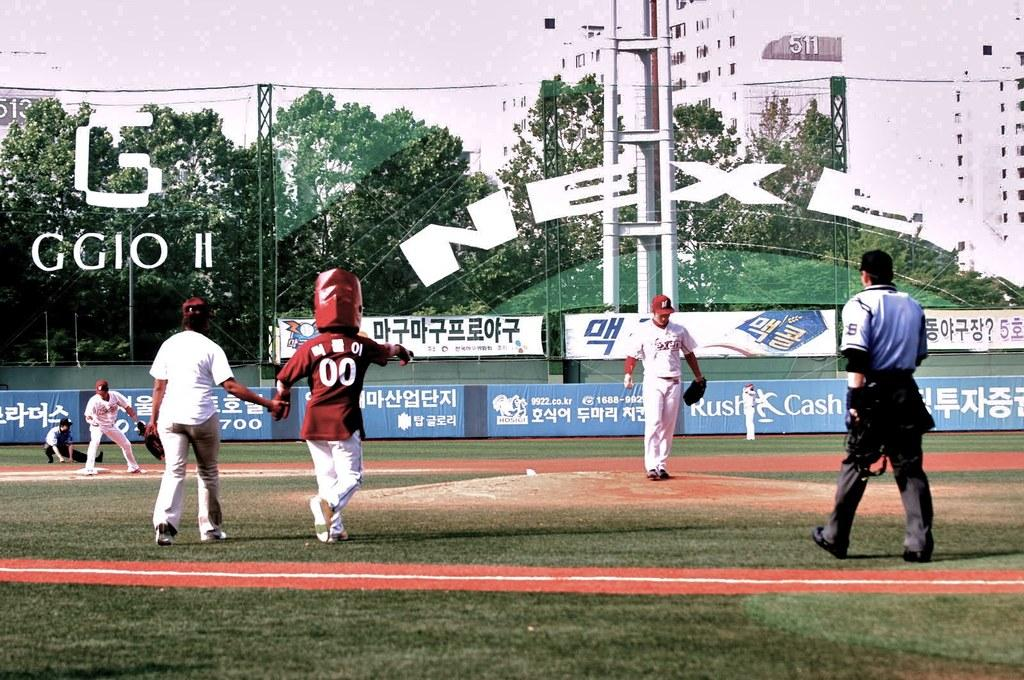<image>
Describe the image concisely. Someone with the number 00 on their jersey has a huge thing on their head. 